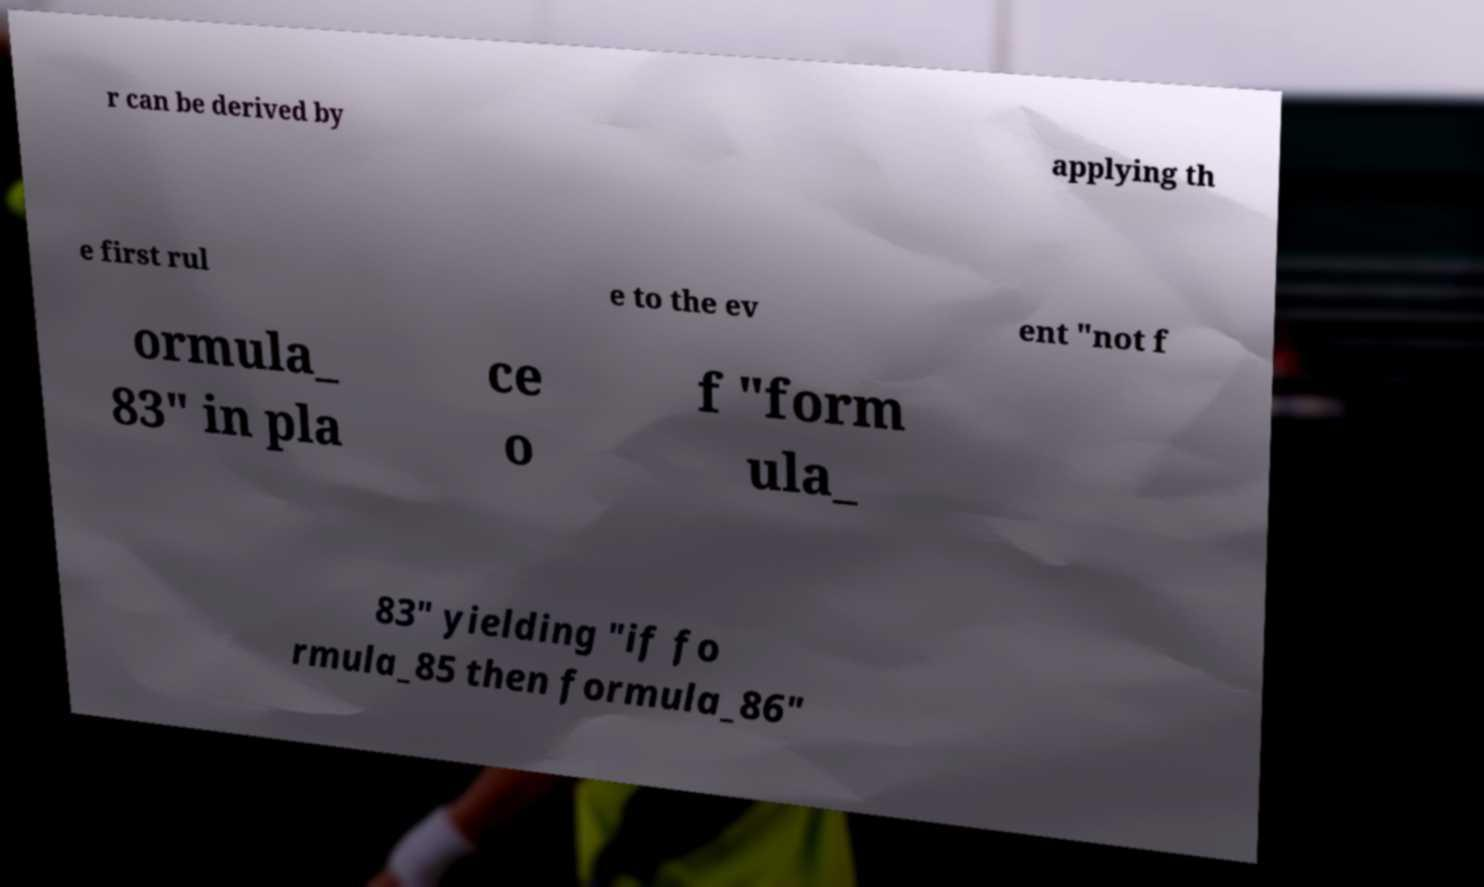What messages or text are displayed in this image? I need them in a readable, typed format. r can be derived by applying th e first rul e to the ev ent "not f ormula_ 83" in pla ce o f "form ula_ 83" yielding "if fo rmula_85 then formula_86" 